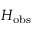<formula> <loc_0><loc_0><loc_500><loc_500>H _ { o b s }</formula> 